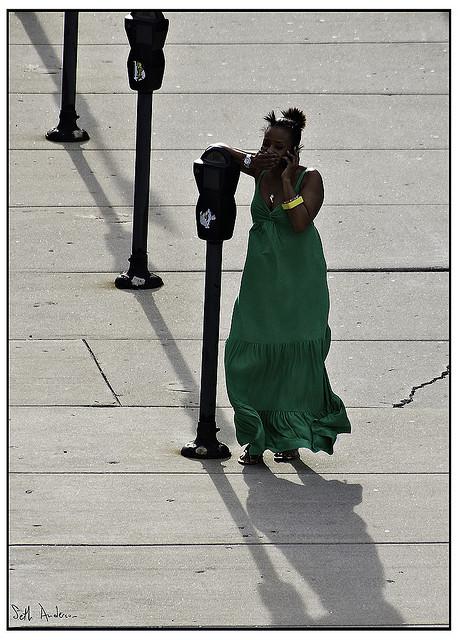What is the woman leaning on?
Keep it brief. Parking meter. What is the woman doing?
Answer briefly. Talking on phone. What color is her dress?
Write a very short answer. Green. 